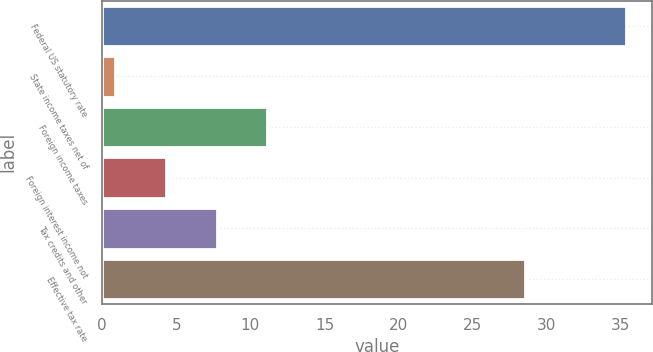Convert chart to OTSL. <chart><loc_0><loc_0><loc_500><loc_500><bar_chart><fcel>Federal US statutory rate<fcel>State income taxes net of<fcel>Foreign income taxes<fcel>Foreign interest income not<fcel>Tax credits and other<fcel>Effective tax rate<nl><fcel>35.32<fcel>0.9<fcel>11.13<fcel>4.31<fcel>7.72<fcel>28.5<nl></chart> 